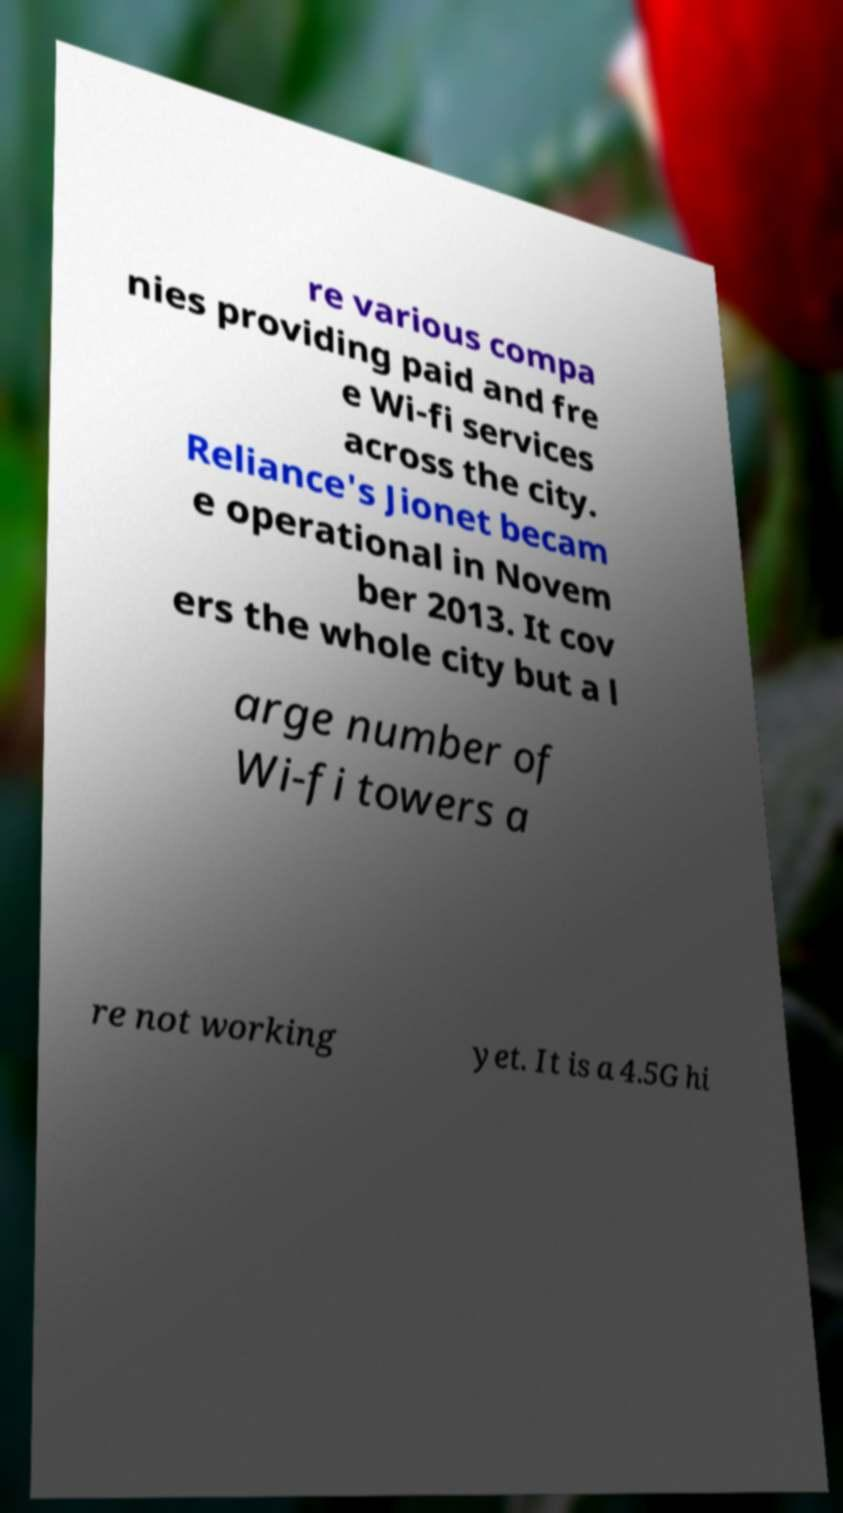What messages or text are displayed in this image? I need them in a readable, typed format. re various compa nies providing paid and fre e Wi-fi services across the city. Reliance's Jionet becam e operational in Novem ber 2013. It cov ers the whole city but a l arge number of Wi-fi towers a re not working yet. It is a 4.5G hi 